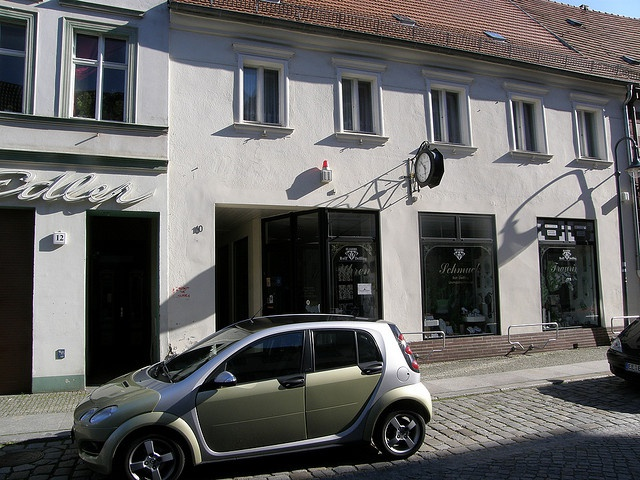Describe the objects in this image and their specific colors. I can see car in darkgray, black, gray, and white tones, car in darkgray, black, and gray tones, and clock in darkgray, black, gray, and lightgray tones in this image. 